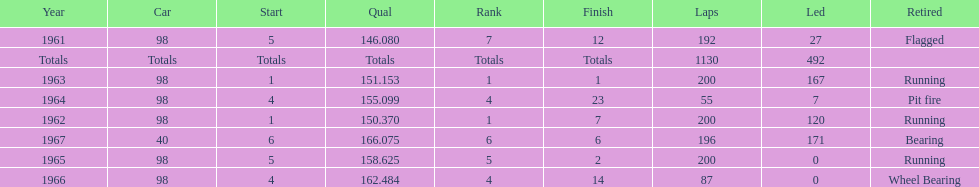What was his best finish before his first win? 7. 